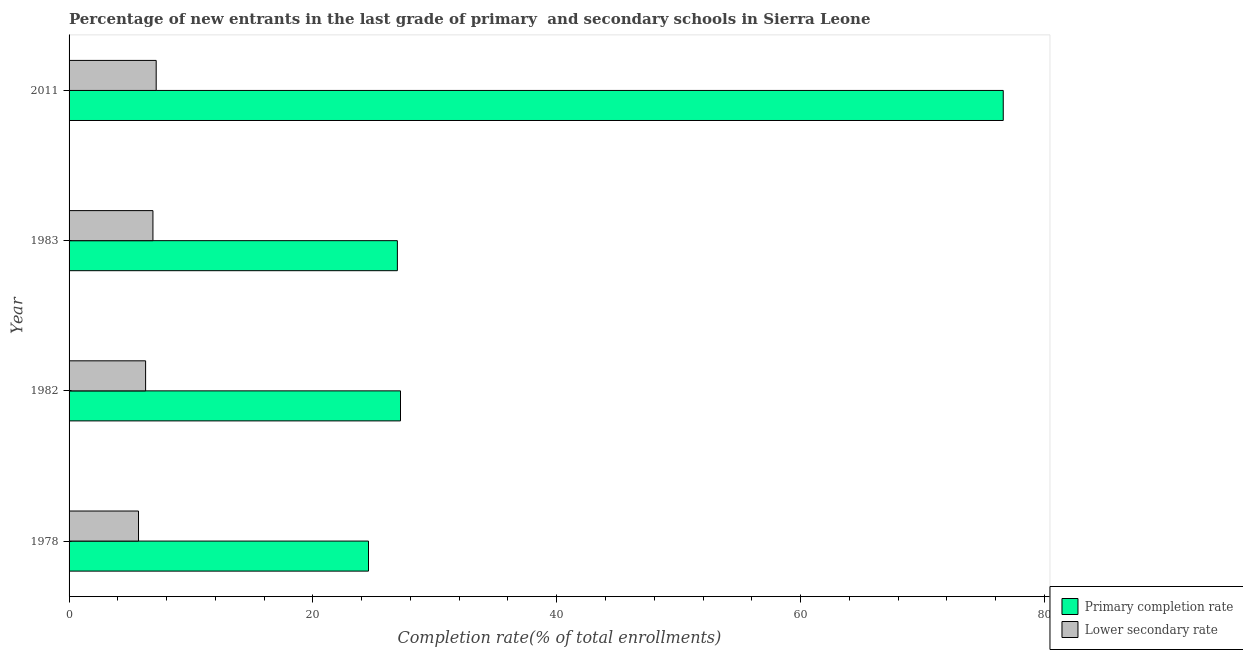Are the number of bars on each tick of the Y-axis equal?
Your response must be concise. Yes. How many bars are there on the 3rd tick from the top?
Make the answer very short. 2. How many bars are there on the 1st tick from the bottom?
Your response must be concise. 2. What is the completion rate in primary schools in 2011?
Make the answer very short. 76.62. Across all years, what is the maximum completion rate in primary schools?
Provide a succinct answer. 76.62. Across all years, what is the minimum completion rate in secondary schools?
Provide a succinct answer. 5.7. In which year was the completion rate in primary schools maximum?
Give a very brief answer. 2011. In which year was the completion rate in secondary schools minimum?
Your response must be concise. 1978. What is the total completion rate in secondary schools in the graph?
Give a very brief answer. 26. What is the difference between the completion rate in secondary schools in 1982 and that in 1983?
Your answer should be very brief. -0.6. What is the difference between the completion rate in primary schools in 2011 and the completion rate in secondary schools in 1982?
Give a very brief answer. 70.34. What is the average completion rate in secondary schools per year?
Your response must be concise. 6.5. In the year 1982, what is the difference between the completion rate in primary schools and completion rate in secondary schools?
Give a very brief answer. 20.91. Is the completion rate in secondary schools in 1978 less than that in 1982?
Your answer should be compact. Yes. What is the difference between the highest and the second highest completion rate in secondary schools?
Make the answer very short. 0.27. What is the difference between the highest and the lowest completion rate in secondary schools?
Your answer should be very brief. 1.45. Is the sum of the completion rate in primary schools in 1983 and 2011 greater than the maximum completion rate in secondary schools across all years?
Keep it short and to the point. Yes. What does the 1st bar from the top in 1983 represents?
Keep it short and to the point. Lower secondary rate. What does the 2nd bar from the bottom in 2011 represents?
Offer a very short reply. Lower secondary rate. How many bars are there?
Ensure brevity in your answer.  8. How many years are there in the graph?
Your answer should be compact. 4. Does the graph contain any zero values?
Your answer should be compact. No. Does the graph contain grids?
Ensure brevity in your answer.  No. Where does the legend appear in the graph?
Your answer should be compact. Bottom right. How are the legend labels stacked?
Give a very brief answer. Vertical. What is the title of the graph?
Provide a short and direct response. Percentage of new entrants in the last grade of primary  and secondary schools in Sierra Leone. What is the label or title of the X-axis?
Offer a terse response. Completion rate(% of total enrollments). What is the label or title of the Y-axis?
Offer a very short reply. Year. What is the Completion rate(% of total enrollments) of Primary completion rate in 1978?
Ensure brevity in your answer.  24.56. What is the Completion rate(% of total enrollments) of Lower secondary rate in 1978?
Offer a very short reply. 5.7. What is the Completion rate(% of total enrollments) in Primary completion rate in 1982?
Give a very brief answer. 27.18. What is the Completion rate(% of total enrollments) in Lower secondary rate in 1982?
Make the answer very short. 6.28. What is the Completion rate(% of total enrollments) in Primary completion rate in 1983?
Keep it short and to the point. 26.93. What is the Completion rate(% of total enrollments) of Lower secondary rate in 1983?
Ensure brevity in your answer.  6.88. What is the Completion rate(% of total enrollments) of Primary completion rate in 2011?
Your response must be concise. 76.62. What is the Completion rate(% of total enrollments) of Lower secondary rate in 2011?
Provide a succinct answer. 7.15. Across all years, what is the maximum Completion rate(% of total enrollments) of Primary completion rate?
Keep it short and to the point. 76.62. Across all years, what is the maximum Completion rate(% of total enrollments) in Lower secondary rate?
Make the answer very short. 7.15. Across all years, what is the minimum Completion rate(% of total enrollments) of Primary completion rate?
Provide a short and direct response. 24.56. Across all years, what is the minimum Completion rate(% of total enrollments) of Lower secondary rate?
Keep it short and to the point. 5.7. What is the total Completion rate(% of total enrollments) of Primary completion rate in the graph?
Keep it short and to the point. 155.29. What is the total Completion rate(% of total enrollments) of Lower secondary rate in the graph?
Your response must be concise. 26. What is the difference between the Completion rate(% of total enrollments) of Primary completion rate in 1978 and that in 1982?
Provide a succinct answer. -2.63. What is the difference between the Completion rate(% of total enrollments) of Lower secondary rate in 1978 and that in 1982?
Offer a very short reply. -0.58. What is the difference between the Completion rate(% of total enrollments) of Primary completion rate in 1978 and that in 1983?
Provide a succinct answer. -2.37. What is the difference between the Completion rate(% of total enrollments) in Lower secondary rate in 1978 and that in 1983?
Keep it short and to the point. -1.18. What is the difference between the Completion rate(% of total enrollments) of Primary completion rate in 1978 and that in 2011?
Make the answer very short. -52.06. What is the difference between the Completion rate(% of total enrollments) in Lower secondary rate in 1978 and that in 2011?
Give a very brief answer. -1.45. What is the difference between the Completion rate(% of total enrollments) of Primary completion rate in 1982 and that in 1983?
Your answer should be compact. 0.26. What is the difference between the Completion rate(% of total enrollments) in Lower secondary rate in 1982 and that in 1983?
Make the answer very short. -0.6. What is the difference between the Completion rate(% of total enrollments) in Primary completion rate in 1982 and that in 2011?
Ensure brevity in your answer.  -49.44. What is the difference between the Completion rate(% of total enrollments) in Lower secondary rate in 1982 and that in 2011?
Your response must be concise. -0.87. What is the difference between the Completion rate(% of total enrollments) of Primary completion rate in 1983 and that in 2011?
Your response must be concise. -49.69. What is the difference between the Completion rate(% of total enrollments) of Lower secondary rate in 1983 and that in 2011?
Your answer should be compact. -0.27. What is the difference between the Completion rate(% of total enrollments) in Primary completion rate in 1978 and the Completion rate(% of total enrollments) in Lower secondary rate in 1982?
Your answer should be compact. 18.28. What is the difference between the Completion rate(% of total enrollments) in Primary completion rate in 1978 and the Completion rate(% of total enrollments) in Lower secondary rate in 1983?
Make the answer very short. 17.68. What is the difference between the Completion rate(% of total enrollments) of Primary completion rate in 1978 and the Completion rate(% of total enrollments) of Lower secondary rate in 2011?
Provide a succinct answer. 17.41. What is the difference between the Completion rate(% of total enrollments) of Primary completion rate in 1982 and the Completion rate(% of total enrollments) of Lower secondary rate in 1983?
Your answer should be very brief. 20.3. What is the difference between the Completion rate(% of total enrollments) of Primary completion rate in 1982 and the Completion rate(% of total enrollments) of Lower secondary rate in 2011?
Ensure brevity in your answer.  20.04. What is the difference between the Completion rate(% of total enrollments) in Primary completion rate in 1983 and the Completion rate(% of total enrollments) in Lower secondary rate in 2011?
Give a very brief answer. 19.78. What is the average Completion rate(% of total enrollments) in Primary completion rate per year?
Your response must be concise. 38.82. What is the average Completion rate(% of total enrollments) of Lower secondary rate per year?
Your response must be concise. 6.5. In the year 1978, what is the difference between the Completion rate(% of total enrollments) in Primary completion rate and Completion rate(% of total enrollments) in Lower secondary rate?
Your answer should be compact. 18.86. In the year 1982, what is the difference between the Completion rate(% of total enrollments) of Primary completion rate and Completion rate(% of total enrollments) of Lower secondary rate?
Offer a very short reply. 20.91. In the year 1983, what is the difference between the Completion rate(% of total enrollments) of Primary completion rate and Completion rate(% of total enrollments) of Lower secondary rate?
Your response must be concise. 20.05. In the year 2011, what is the difference between the Completion rate(% of total enrollments) in Primary completion rate and Completion rate(% of total enrollments) in Lower secondary rate?
Your answer should be very brief. 69.48. What is the ratio of the Completion rate(% of total enrollments) of Primary completion rate in 1978 to that in 1982?
Offer a terse response. 0.9. What is the ratio of the Completion rate(% of total enrollments) of Lower secondary rate in 1978 to that in 1982?
Provide a succinct answer. 0.91. What is the ratio of the Completion rate(% of total enrollments) in Primary completion rate in 1978 to that in 1983?
Give a very brief answer. 0.91. What is the ratio of the Completion rate(% of total enrollments) of Lower secondary rate in 1978 to that in 1983?
Provide a succinct answer. 0.83. What is the ratio of the Completion rate(% of total enrollments) in Primary completion rate in 1978 to that in 2011?
Your answer should be very brief. 0.32. What is the ratio of the Completion rate(% of total enrollments) in Lower secondary rate in 1978 to that in 2011?
Provide a succinct answer. 0.8. What is the ratio of the Completion rate(% of total enrollments) of Primary completion rate in 1982 to that in 1983?
Offer a terse response. 1.01. What is the ratio of the Completion rate(% of total enrollments) of Lower secondary rate in 1982 to that in 1983?
Ensure brevity in your answer.  0.91. What is the ratio of the Completion rate(% of total enrollments) of Primary completion rate in 1982 to that in 2011?
Make the answer very short. 0.35. What is the ratio of the Completion rate(% of total enrollments) in Lower secondary rate in 1982 to that in 2011?
Keep it short and to the point. 0.88. What is the ratio of the Completion rate(% of total enrollments) of Primary completion rate in 1983 to that in 2011?
Offer a very short reply. 0.35. What is the ratio of the Completion rate(% of total enrollments) in Lower secondary rate in 1983 to that in 2011?
Keep it short and to the point. 0.96. What is the difference between the highest and the second highest Completion rate(% of total enrollments) in Primary completion rate?
Provide a succinct answer. 49.44. What is the difference between the highest and the second highest Completion rate(% of total enrollments) in Lower secondary rate?
Ensure brevity in your answer.  0.27. What is the difference between the highest and the lowest Completion rate(% of total enrollments) in Primary completion rate?
Your answer should be very brief. 52.06. What is the difference between the highest and the lowest Completion rate(% of total enrollments) of Lower secondary rate?
Offer a very short reply. 1.45. 